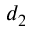<formula> <loc_0><loc_0><loc_500><loc_500>d _ { 2 }</formula> 